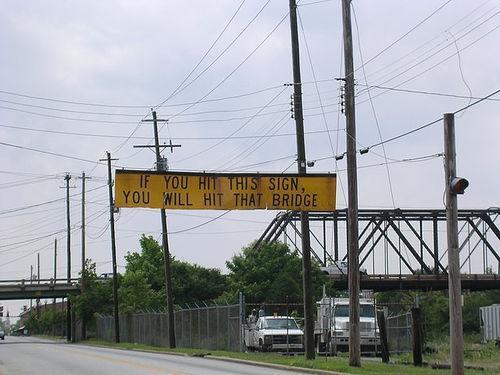How many cars on the road?
Give a very brief answer. 1. 